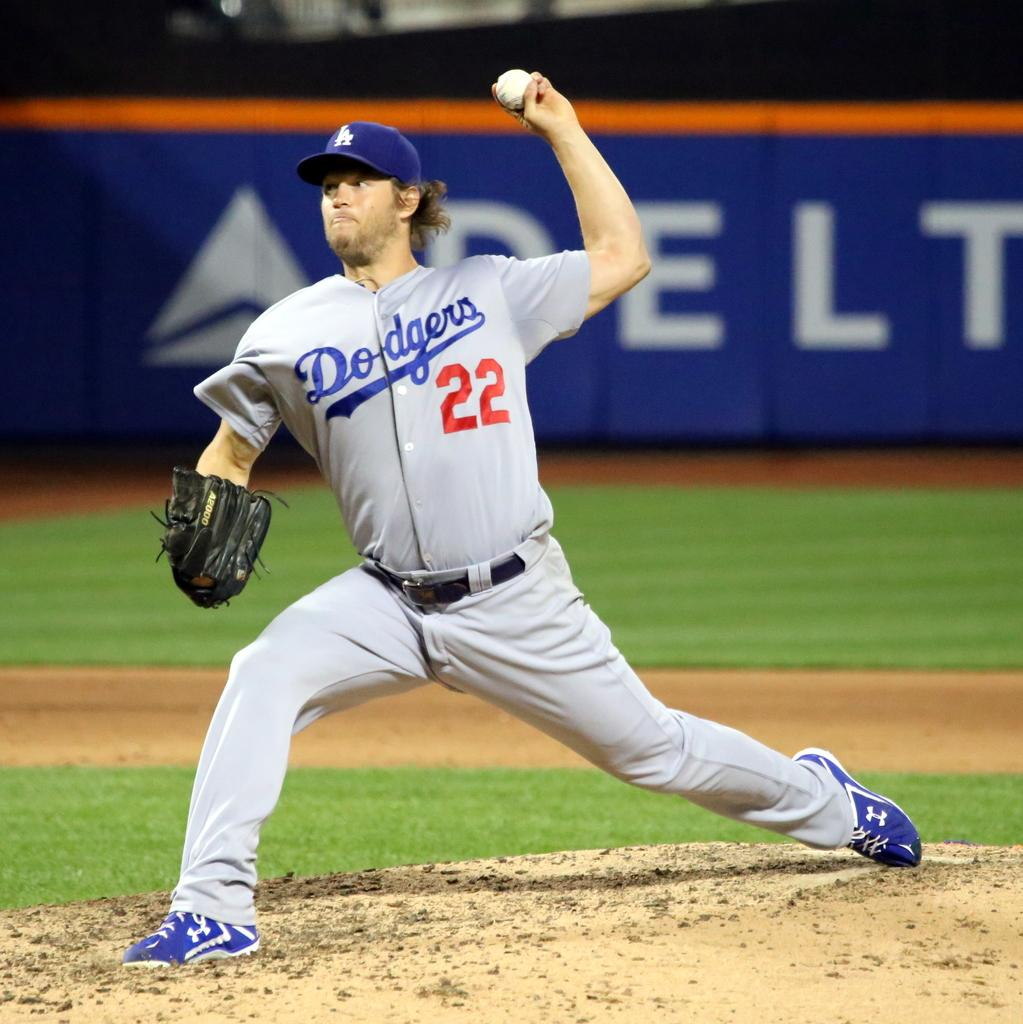<image>
Share a concise interpretation of the image provided. dodgers pitcher #22 throwing the ball in front of delta sign on wall 